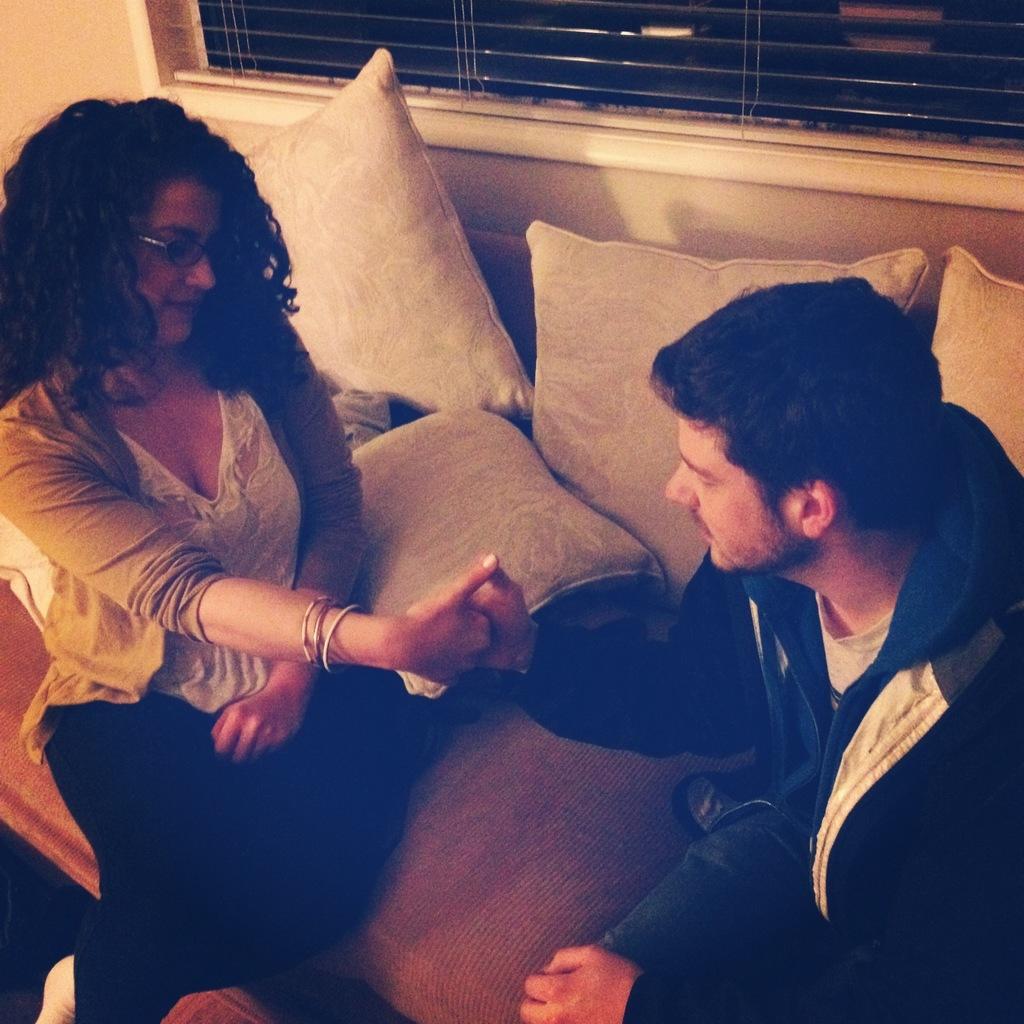Describe this image in one or two sentences. In this image there is a man and woman sitting on sofa in front of pillows and giving shake hand, behind them there is a window. 